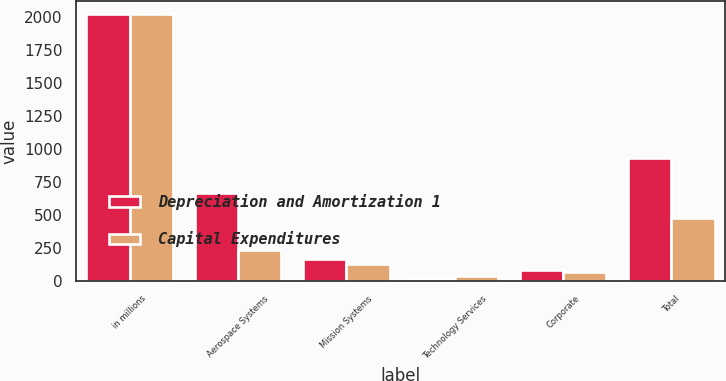<chart> <loc_0><loc_0><loc_500><loc_500><stacked_bar_chart><ecel><fcel>in millions<fcel>Aerospace Systems<fcel>Mission Systems<fcel>Technology Services<fcel>Corporate<fcel>Total<nl><fcel>Depreciation and Amortization 1<fcel>2017<fcel>665<fcel>164<fcel>15<fcel>84<fcel>928<nl><fcel>Capital Expenditures<fcel>2017<fcel>234<fcel>131<fcel>40<fcel>70<fcel>475<nl></chart> 